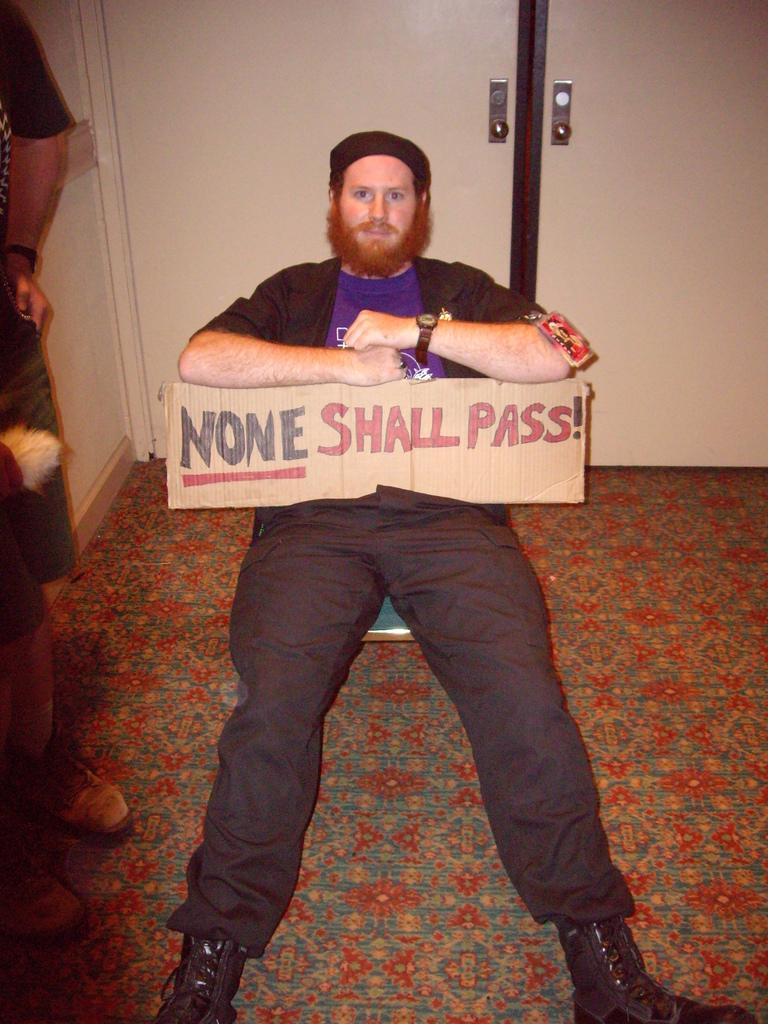What is the man in the image doing? The man is sitting on the floor in the image. What is the man holding in the image? The man is holding a cardboard sheet. Can you describe the person next to the man? There is another person on the left side of the man. What can be seen behind the man? There is a door visible behind the man. What type of plant is growing in the bathtub in the image? There is no bathtub or plant present in the image. How many turkeys are visible in the image? There are no turkeys present in the image. 